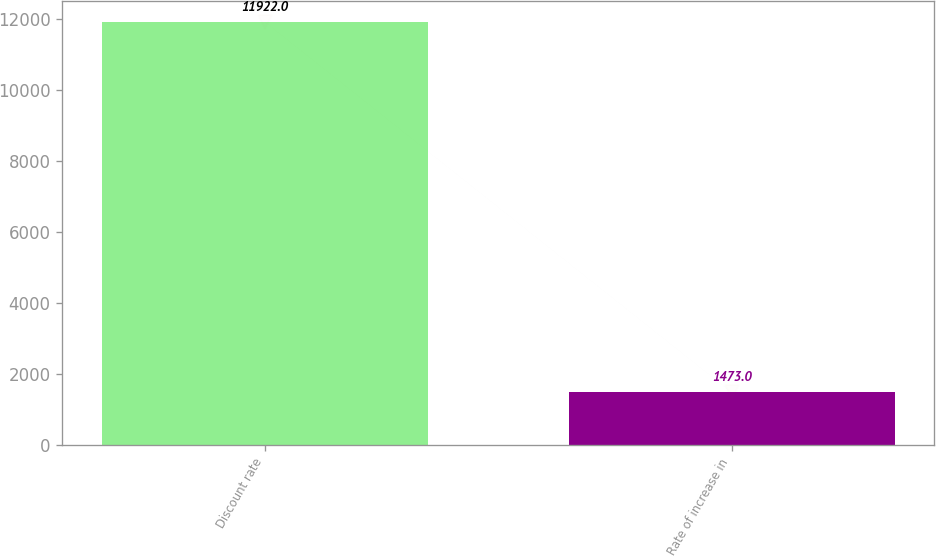Convert chart to OTSL. <chart><loc_0><loc_0><loc_500><loc_500><bar_chart><fcel>Discount rate<fcel>Rate of increase in<nl><fcel>11922<fcel>1473<nl></chart> 